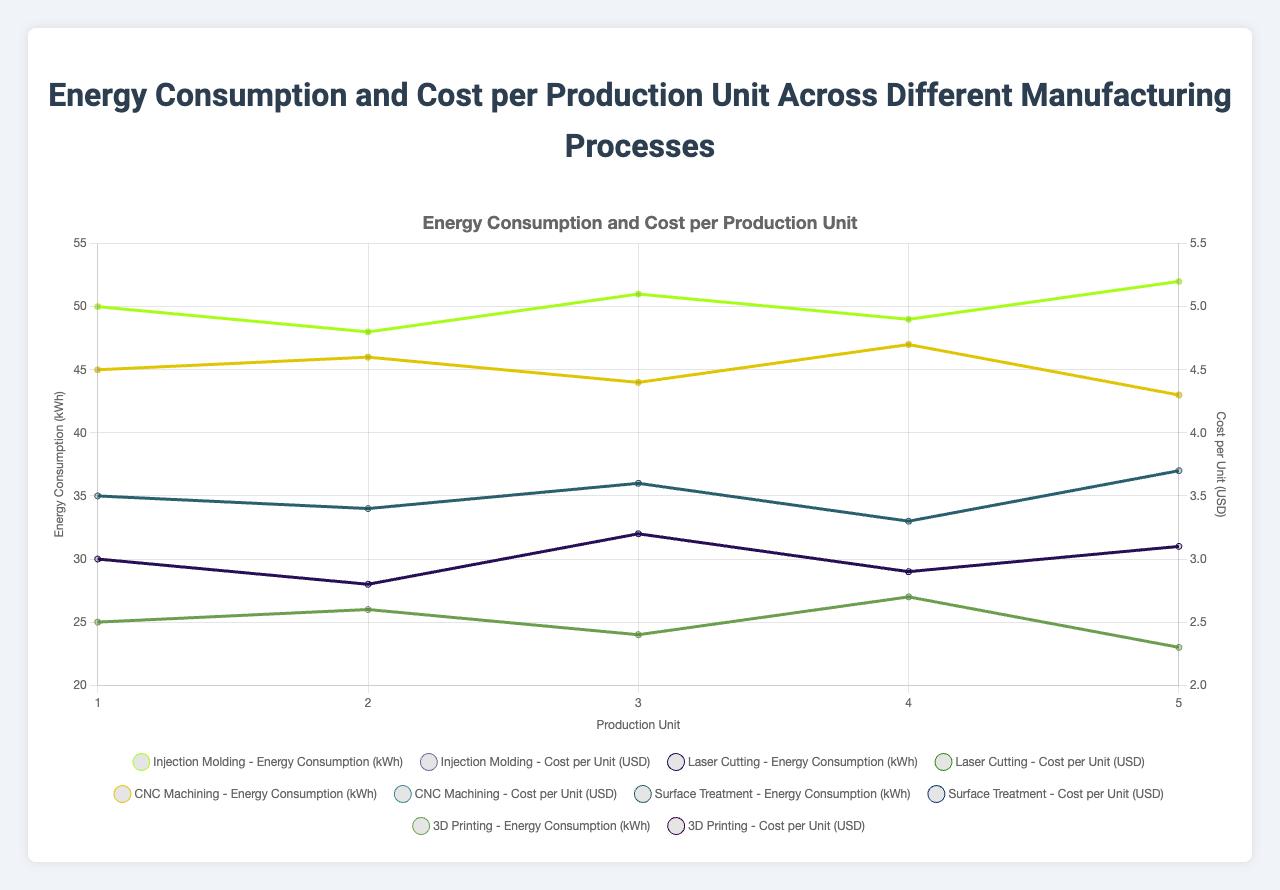What is the average energy consumption for Injection Molding across all production units? Calculate the sum of energy consumption for Injection Molding (50 + 48 + 51 + 49 + 52 = 250) and divide by the number of units (5). The result is 250/5 = 50
Answer: 50 Between Injection Molding and CNC Machining, which process has a higher average cost per unit? Calculate the average cost per unit for Injection Molding (sum of cost per unit: 5 + 4.8 + 5.1 + 4.9 + 5.2 = 25; average = 25/5 = 5). Calculate the average cost per unit for CNC Machining (sum of cost per unit: 4.5 + 4.6 + 4.4 + 4.7 + 4.3 = 22.5; average = 22.5/5 = 4.5). Compare the two averages: 5 is greater than 4.5
Answer: Injection Molding How does the energy consumption trend for 3D Printing compare to CNC Machining from production unit 1 to 5? Observing the trend lines on the plot, both 3D Printing and CNC Machining show a slight decrease in energy consumption with some fluctuations. 3D Printing starts at 25 kWh and ends at 23 kWh, while CNC Machining starts at 45 kWh and ends at 43 kWh
Answer: Both decrease Which process has the least variation in energy consumption across its production units, Laser Cutting or Surface Treatment? Evaluate the range of energy consumption for each process. For Laser Cutting, calculate the range (max-min: 32 - 28 = 4). For Surface Treatment, calculate the range (max-min: 37 - 33 = 4). Both processes have the same range of energy consumption
Answer: Both What is the total cost of production for 3D Printing over five production units? Calculate the sum of the cost per unit for 3D Printing (2.5 + 2.6 + 2.4 + 2.7 + 2.3 = 12.5)
Answer: 12.5 Which production unit shows the highest energy consumption for Injection Molding? Referring to the energy consumption values for Injection Molding, the production unit with the highest value is unit 5 with 52 kWh
Answer: Unit 5 Is the energy consumption for any process consistent across all production units? By examining the energy consumption lines for each process, it is observed that none of the processes have an energy consumption that is completely consistent (flat line) across all production units
Answer: No What is the difference in cost between the highest and lowest unit cost for Laser Cutting? Identify the highest and lowest unit costs for Laser Cutting (max = 3.2, min = 2.8), and calculate the difference (3.2 - 2.8 = 0.4)
Answer: 0.4 